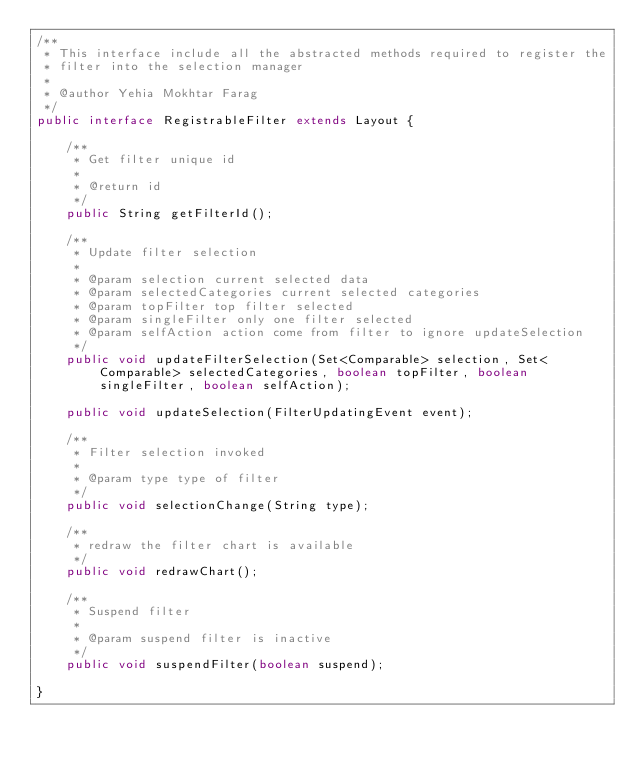<code> <loc_0><loc_0><loc_500><loc_500><_Java_>/**
 * This interface include all the abstracted methods required to register the
 * filter into the selection manager
 *
 * @author Yehia Mokhtar Farag
 */
public interface RegistrableFilter extends Layout {

    /**
     * Get filter unique id
     *
     * @return id
     */
    public String getFilterId();

    /**
     * Update filter selection
     *
     * @param selection current selected data
     * @param selectedCategories current selected categories
     * @param topFilter top filter selected
     * @param singleFilter only one filter selected
     * @param selfAction action come from filter to ignore updateSelection
     */
    public void updateFilterSelection(Set<Comparable> selection, Set<Comparable> selectedCategories, boolean topFilter, boolean singleFilter, boolean selfAction);

    public void updateSelection(FilterUpdatingEvent event);

    /**
     * Filter selection invoked
     *
     * @param type type of filter
     */
    public void selectionChange(String type);

    /**
     * redraw the filter chart is available
     */
    public void redrawChart();

    /**
     * Suspend filter
     *
     * @param suspend filter is inactive
     */
    public void suspendFilter(boolean suspend);

}
</code> 